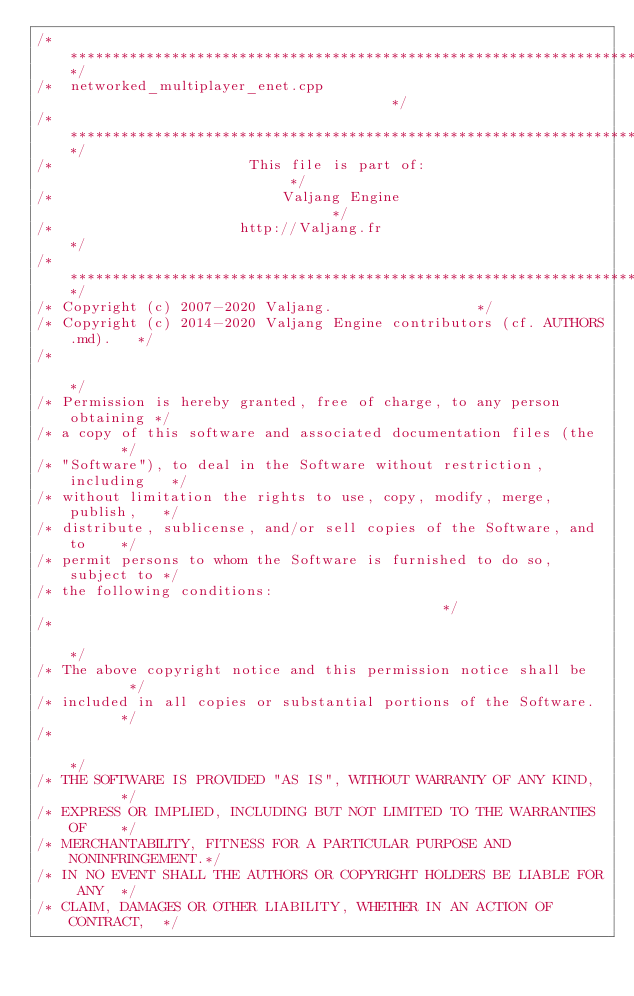Convert code to text. <code><loc_0><loc_0><loc_500><loc_500><_C++_>/*************************************************************************/
/*  networked_multiplayer_enet.cpp                                       */
/*************************************************************************/
/*                       This file is part of:                           */
/*                           Valjang Engine                                */
/*                      http://Valjang.fr                          */
/*************************************************************************/
/* Copyright (c) 2007-2020 Valjang.                 */
/* Copyright (c) 2014-2020 Valjang Engine contributors (cf. AUTHORS.md).   */
/*                                                                       */
/* Permission is hereby granted, free of charge, to any person obtaining */
/* a copy of this software and associated documentation files (the       */
/* "Software"), to deal in the Software without restriction, including   */
/* without limitation the rights to use, copy, modify, merge, publish,   */
/* distribute, sublicense, and/or sell copies of the Software, and to    */
/* permit persons to whom the Software is furnished to do so, subject to */
/* the following conditions:                                             */
/*                                                                       */
/* The above copyright notice and this permission notice shall be        */
/* included in all copies or substantial portions of the Software.       */
/*                                                                       */
/* THE SOFTWARE IS PROVIDED "AS IS", WITHOUT WARRANTY OF ANY KIND,       */
/* EXPRESS OR IMPLIED, INCLUDING BUT NOT LIMITED TO THE WARRANTIES OF    */
/* MERCHANTABILITY, FITNESS FOR A PARTICULAR PURPOSE AND NONINFRINGEMENT.*/
/* IN NO EVENT SHALL THE AUTHORS OR COPYRIGHT HOLDERS BE LIABLE FOR ANY  */
/* CLAIM, DAMAGES OR OTHER LIABILITY, WHETHER IN AN ACTION OF CONTRACT,  */</code> 